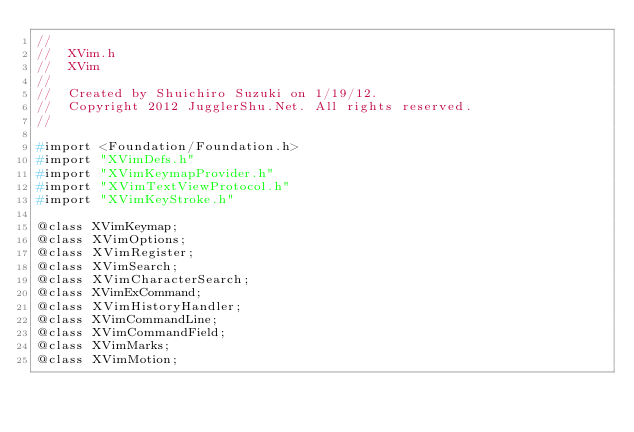<code> <loc_0><loc_0><loc_500><loc_500><_C_>//
//  XVim.h
//  XVim
//
//  Created by Shuichiro Suzuki on 1/19/12.
//  Copyright 2012 JugglerShu.Net. All rights reserved.
//

#import <Foundation/Foundation.h>
#import "XVimDefs.h"
#import "XVimKeymapProvider.h"
#import "XVimTextViewProtocol.h"
#import "XVimKeyStroke.h"

@class XVimKeymap;
@class XVimOptions;
@class XVimRegister;
@class XVimSearch;
@class XVimCharacterSearch;
@class XVimExCommand;
@class XVimHistoryHandler;
@class XVimCommandLine;
@class XVimCommandField;
@class XVimMarks;
@class XVimMotion;</code> 